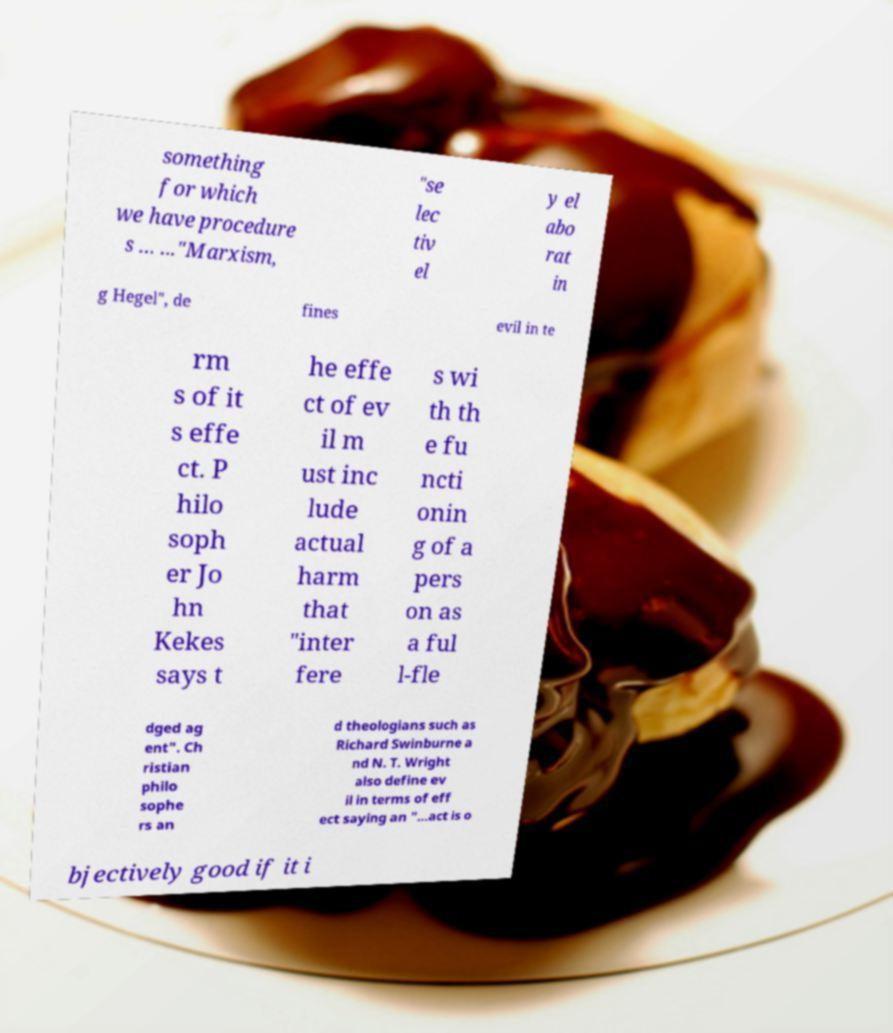Please identify and transcribe the text found in this image. something for which we have procedure s ... ..."Marxism, "se lec tiv el y el abo rat in g Hegel", de fines evil in te rm s of it s effe ct. P hilo soph er Jo hn Kekes says t he effe ct of ev il m ust inc lude actual harm that "inter fere s wi th th e fu ncti onin g of a pers on as a ful l-fle dged ag ent". Ch ristian philo sophe rs an d theologians such as Richard Swinburne a nd N. T. Wright also define ev il in terms of eff ect saying an "...act is o bjectively good if it i 